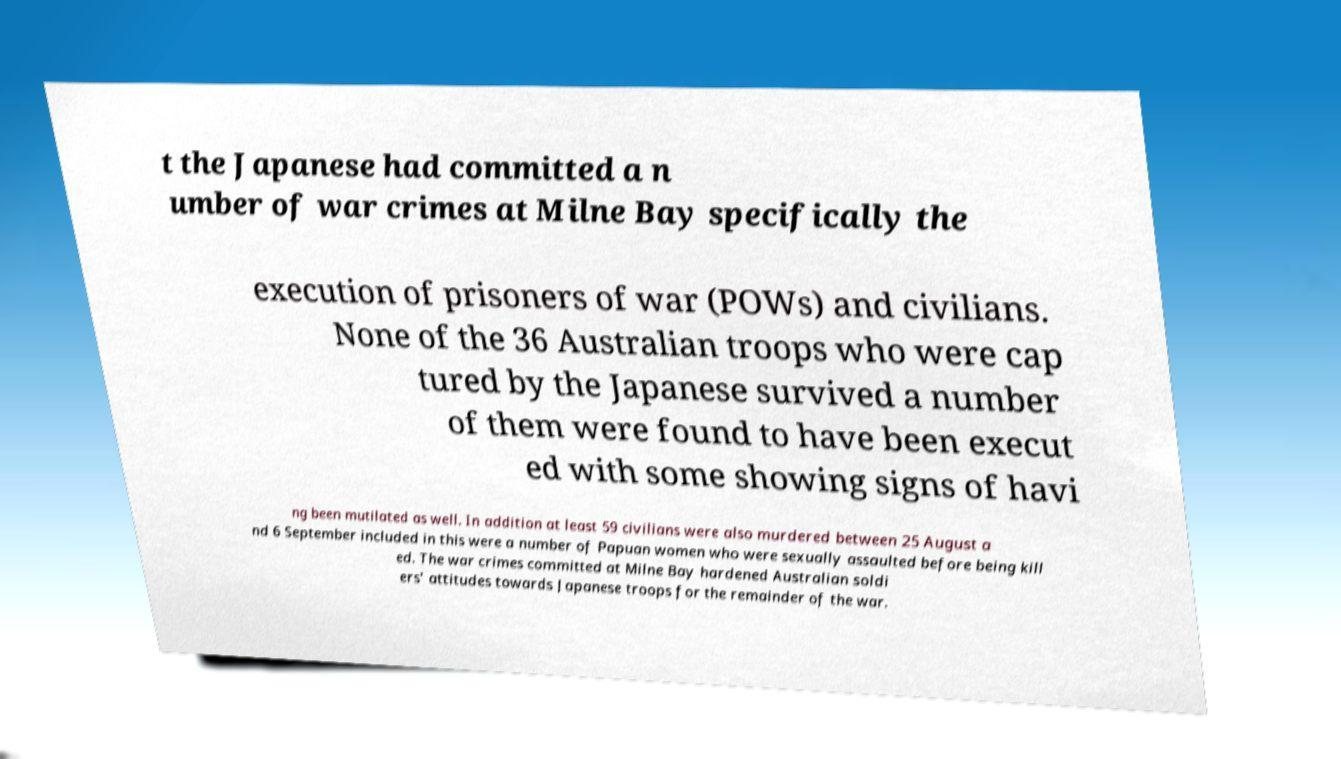Please read and relay the text visible in this image. What does it say? t the Japanese had committed a n umber of war crimes at Milne Bay specifically the execution of prisoners of war (POWs) and civilians. None of the 36 Australian troops who were cap tured by the Japanese survived a number of them were found to have been execut ed with some showing signs of havi ng been mutilated as well. In addition at least 59 civilians were also murdered between 25 August a nd 6 September included in this were a number of Papuan women who were sexually assaulted before being kill ed. The war crimes committed at Milne Bay hardened Australian soldi ers' attitudes towards Japanese troops for the remainder of the war. 